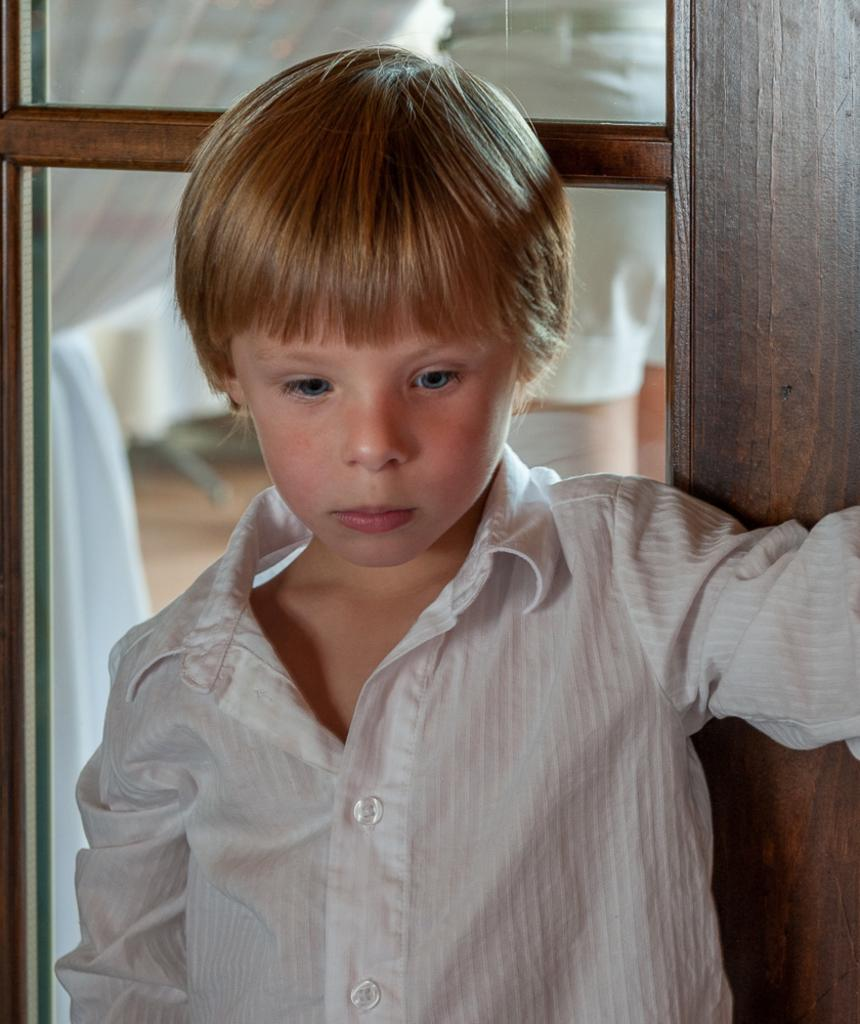What is the main subject of the picture? The main subject of the picture is a kid. What is the kid wearing in the image? The kid is wearing a white dress. What can be seen behind the kid in the image? There is a glass window behind the kid. What type of yarn is the kid playing with in the image? There is no yarn present in the image, and the kid is not playing with any objects. 